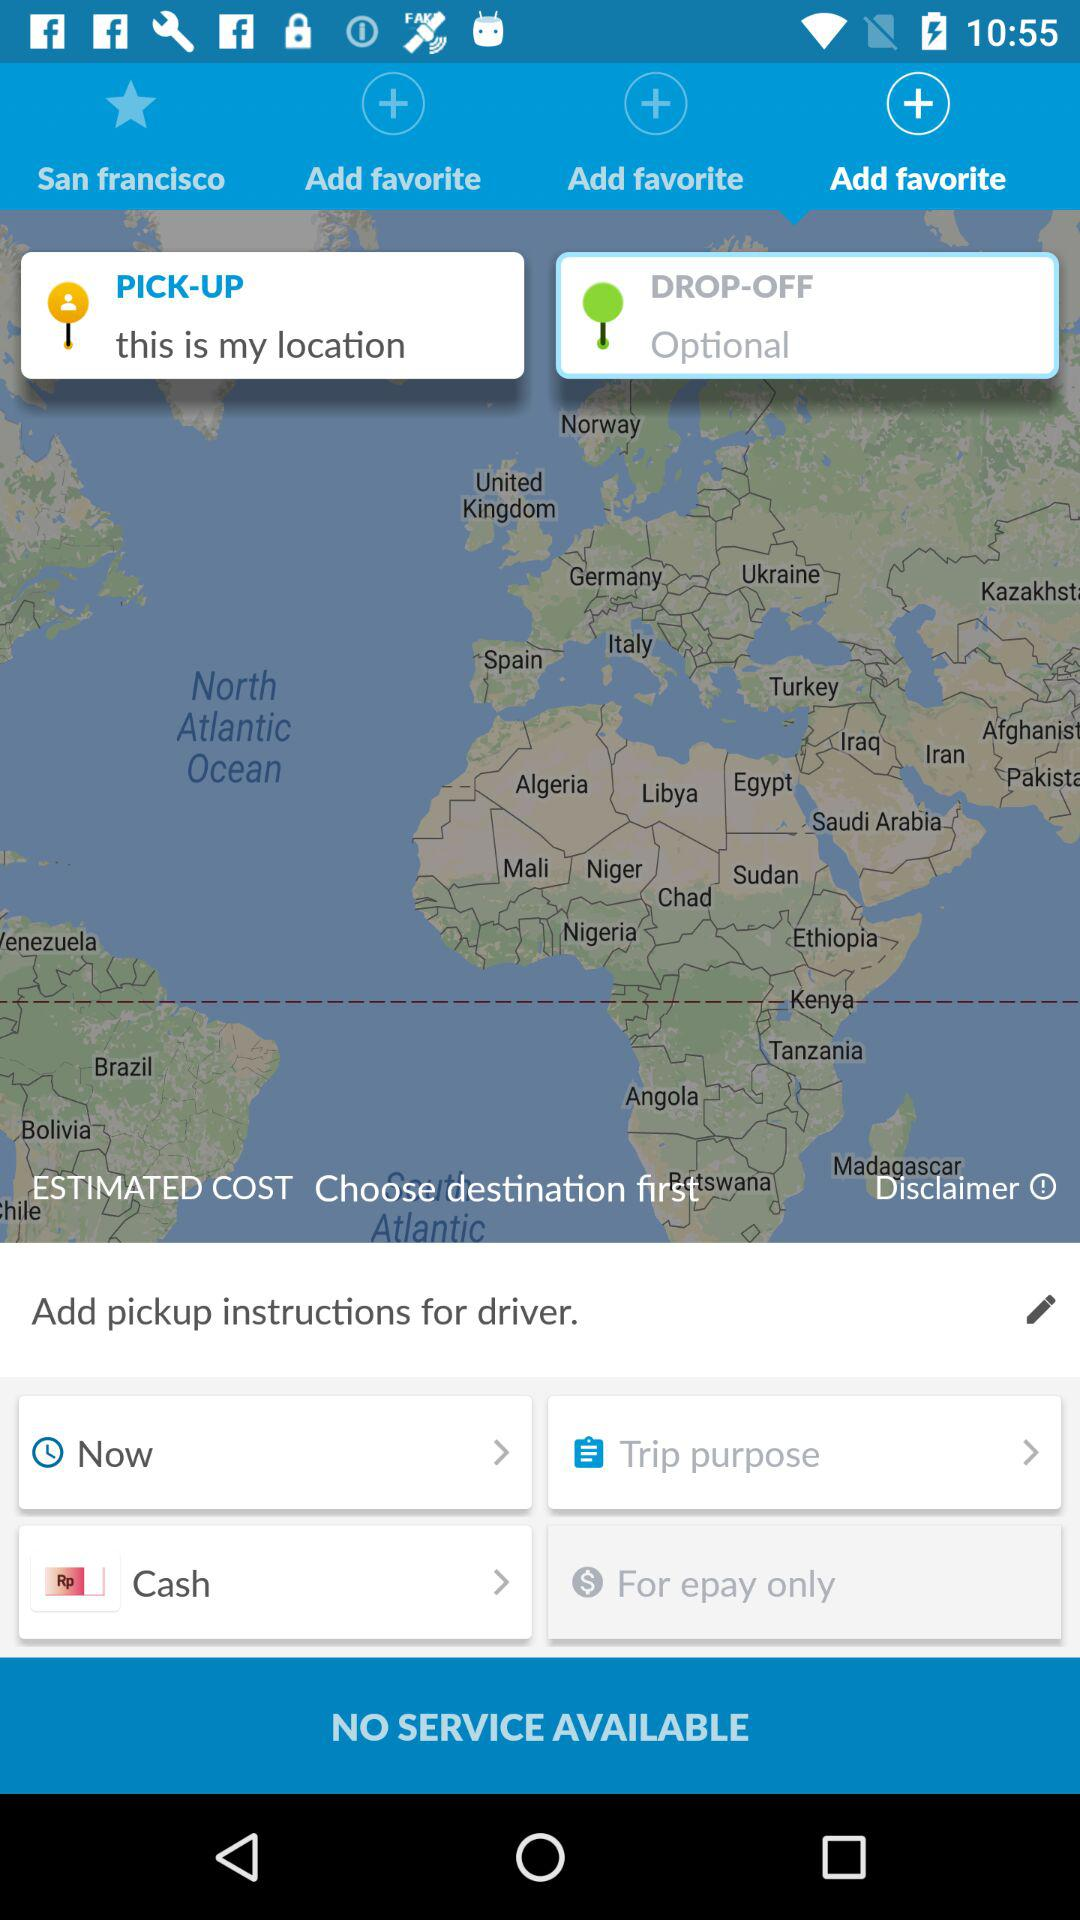What is the selected tab? The selected tabs are "Add favorite" and "PICK-UP". 